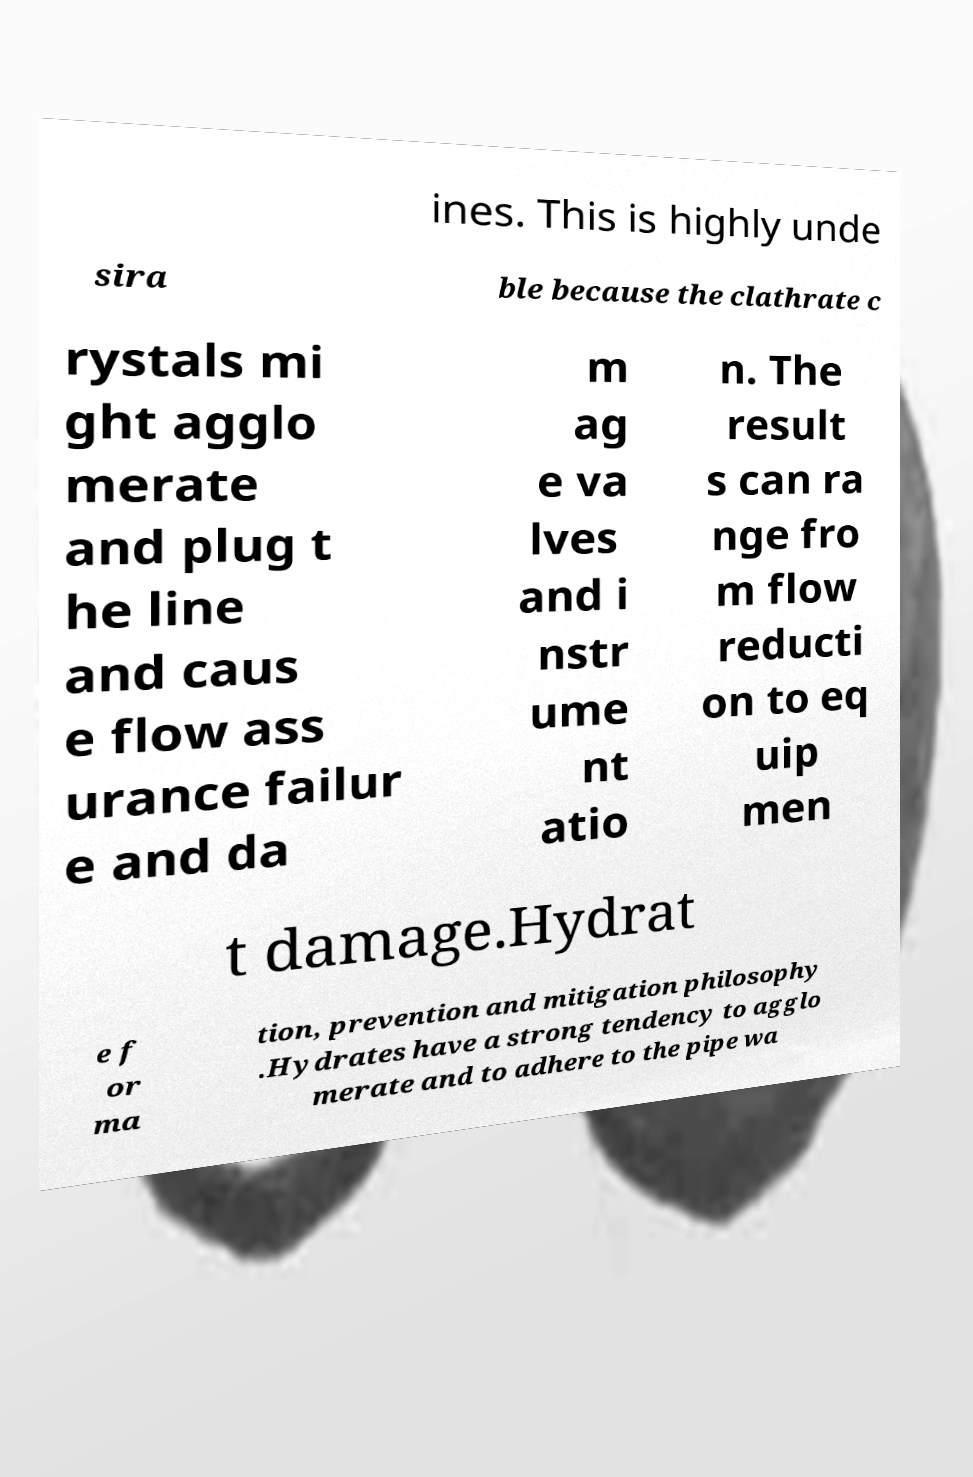What messages or text are displayed in this image? I need them in a readable, typed format. ines. This is highly unde sira ble because the clathrate c rystals mi ght agglo merate and plug t he line and caus e flow ass urance failur e and da m ag e va lves and i nstr ume nt atio n. The result s can ra nge fro m flow reducti on to eq uip men t damage.Hydrat e f or ma tion, prevention and mitigation philosophy .Hydrates have a strong tendency to agglo merate and to adhere to the pipe wa 